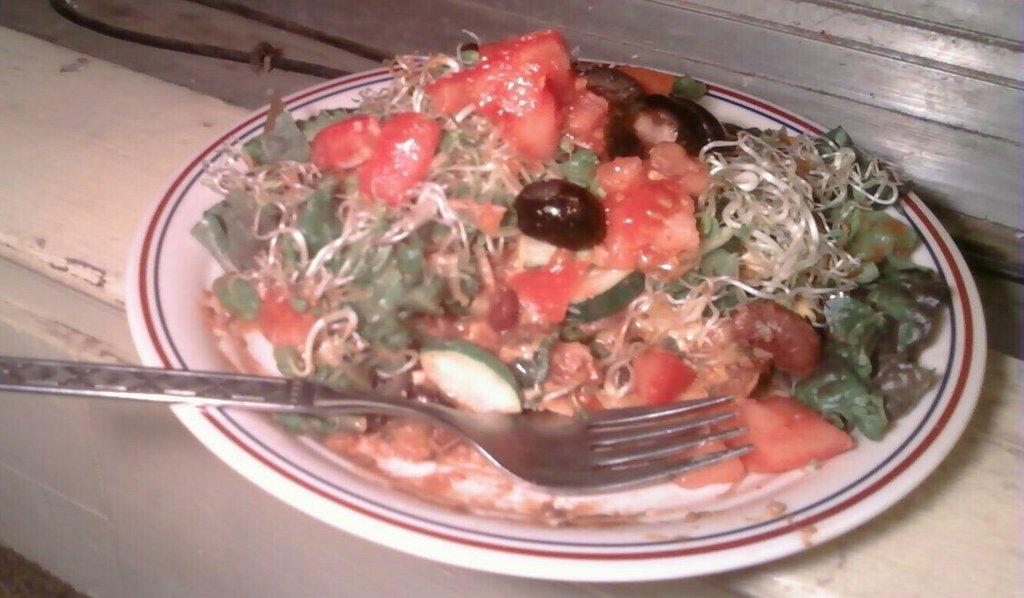In one or two sentences, can you explain what this image depicts? In this picture we can see a plate on an object and on the plate there is a fork and some food items 